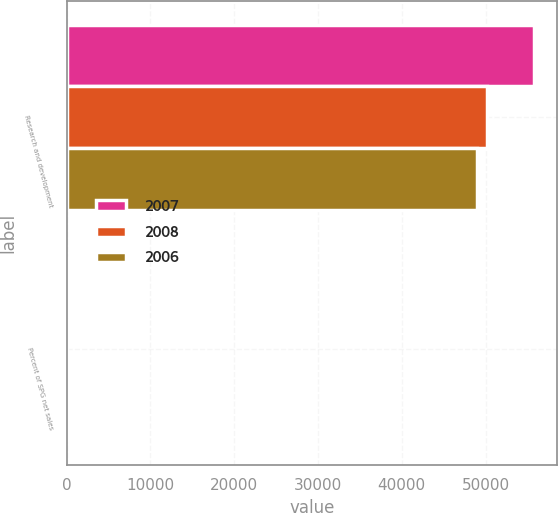Convert chart. <chart><loc_0><loc_0><loc_500><loc_500><stacked_bar_chart><ecel><fcel>Research and development<fcel>Percent of SPG net sales<nl><fcel>2007<fcel>55735<fcel>6.3<nl><fcel>2008<fcel>50213<fcel>6<nl><fcel>2006<fcel>48959<fcel>6.4<nl></chart> 